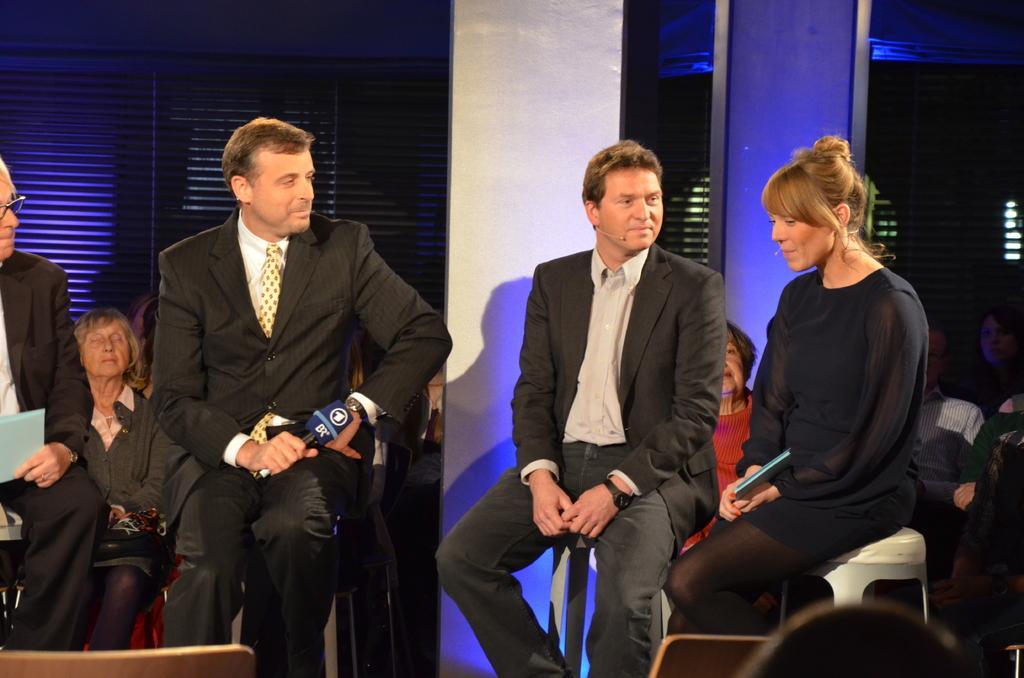In one or two sentences, can you explain what this image depicts? In this image, there are a few people. Among them, some people are holding a few objects. We can see a pillar and the wall with the window blind. We can also see an object with some light. We can also see some objects at the bottom. 